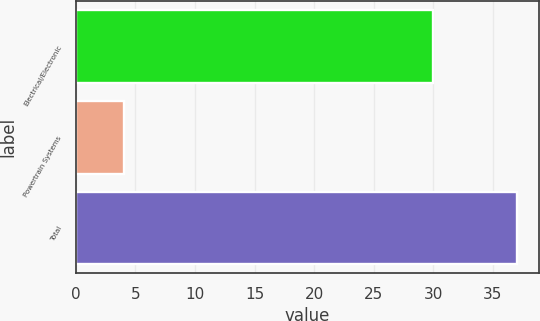Convert chart to OTSL. <chart><loc_0><loc_0><loc_500><loc_500><bar_chart><fcel>Electrical/Electronic<fcel>Powertrain Systems<fcel>Total<nl><fcel>30<fcel>4<fcel>37<nl></chart> 